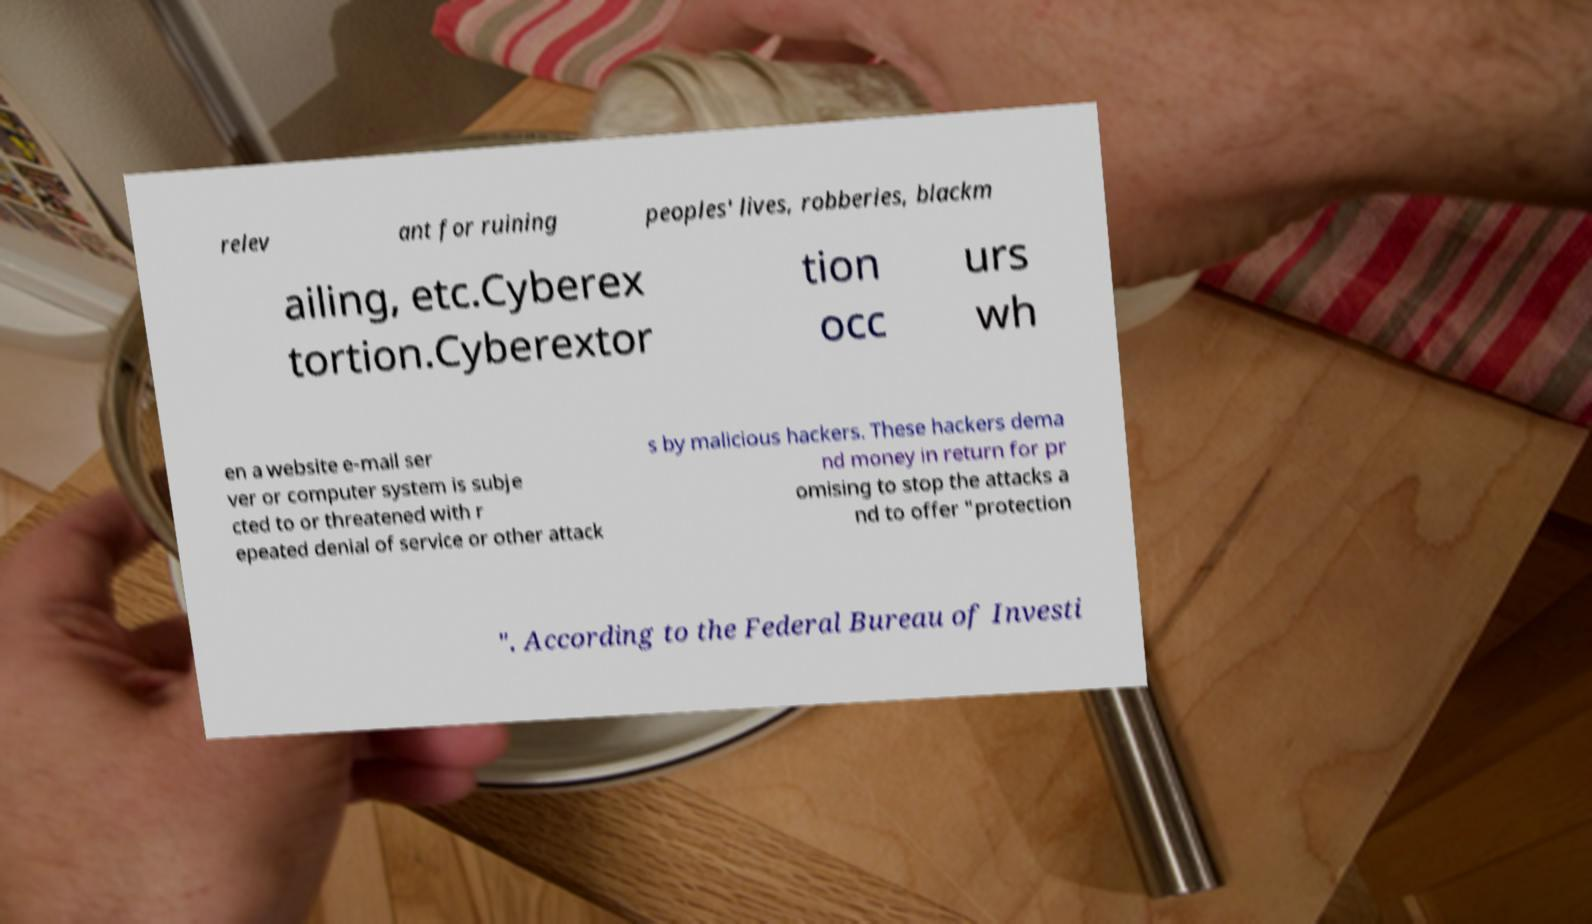What messages or text are displayed in this image? I need them in a readable, typed format. relev ant for ruining peoples' lives, robberies, blackm ailing, etc.Cyberex tortion.Cyberextor tion occ urs wh en a website e-mail ser ver or computer system is subje cted to or threatened with r epeated denial of service or other attack s by malicious hackers. These hackers dema nd money in return for pr omising to stop the attacks a nd to offer "protection ". According to the Federal Bureau of Investi 